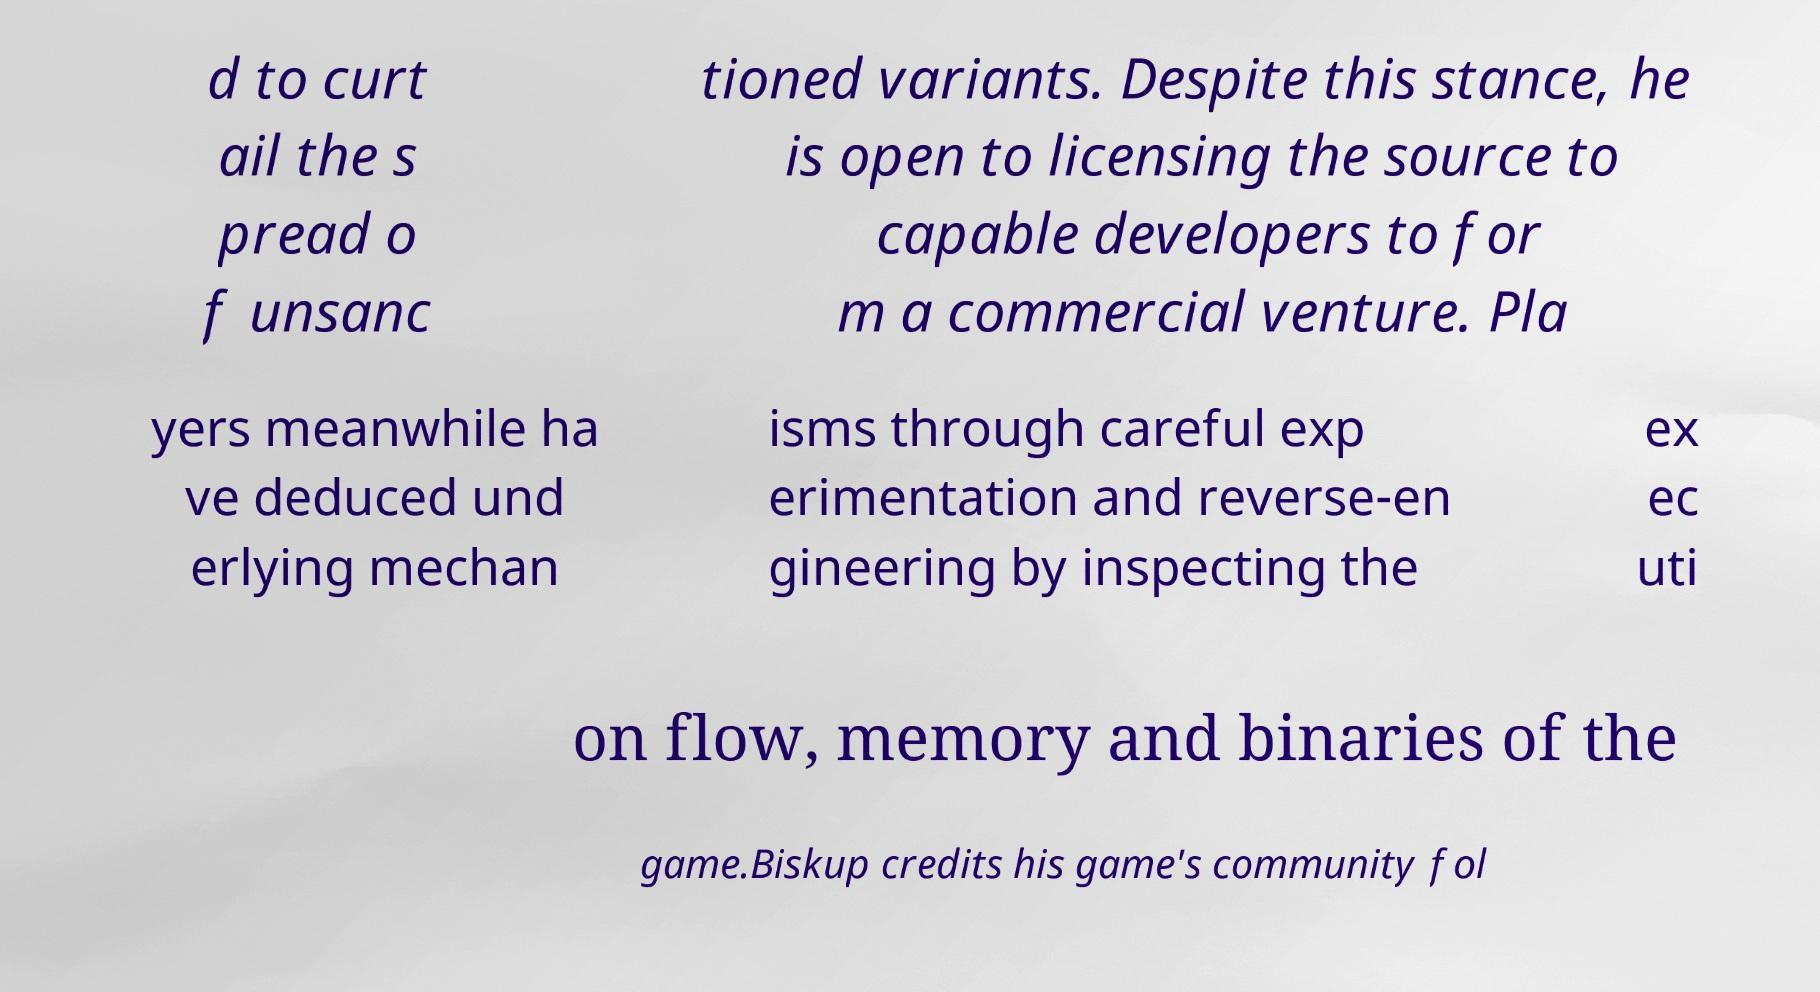I need the written content from this picture converted into text. Can you do that? d to curt ail the s pread o f unsanc tioned variants. Despite this stance, he is open to licensing the source to capable developers to for m a commercial venture. Pla yers meanwhile ha ve deduced und erlying mechan isms through careful exp erimentation and reverse-en gineering by inspecting the ex ec uti on flow, memory and binaries of the game.Biskup credits his game's community fol 